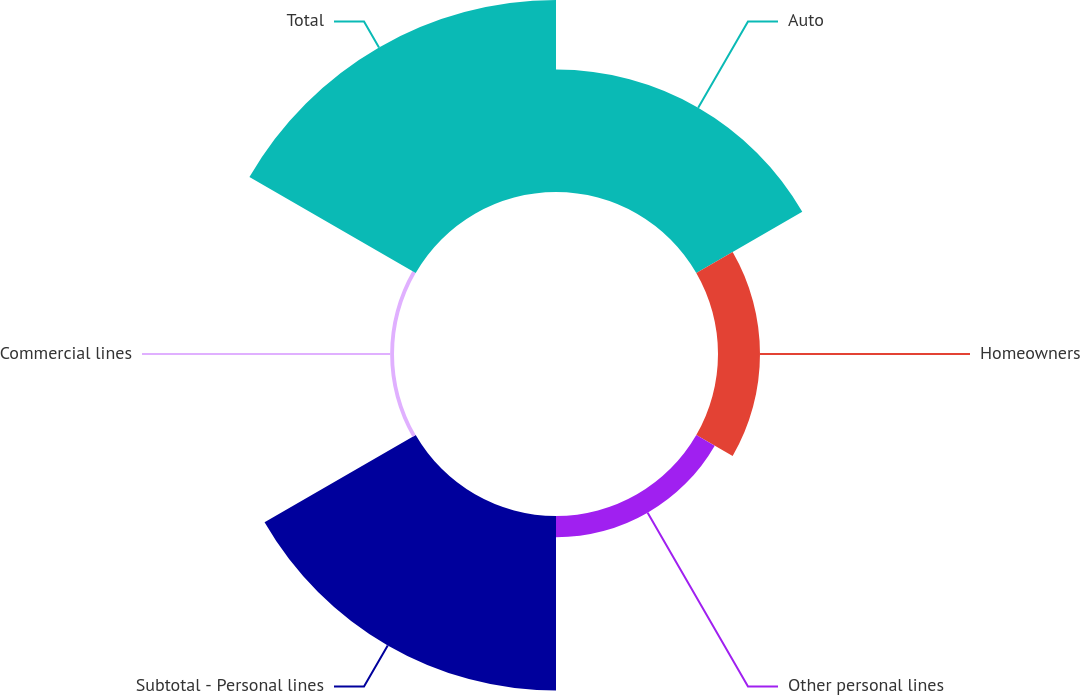Convert chart. <chart><loc_0><loc_0><loc_500><loc_500><pie_chart><fcel>Auto<fcel>Homeowners<fcel>Other personal lines<fcel>Subtotal - Personal lines<fcel>Commercial lines<fcel>Total<nl><fcel>22.01%<fcel>7.55%<fcel>3.83%<fcel>31.39%<fcel>0.69%<fcel>34.53%<nl></chart> 